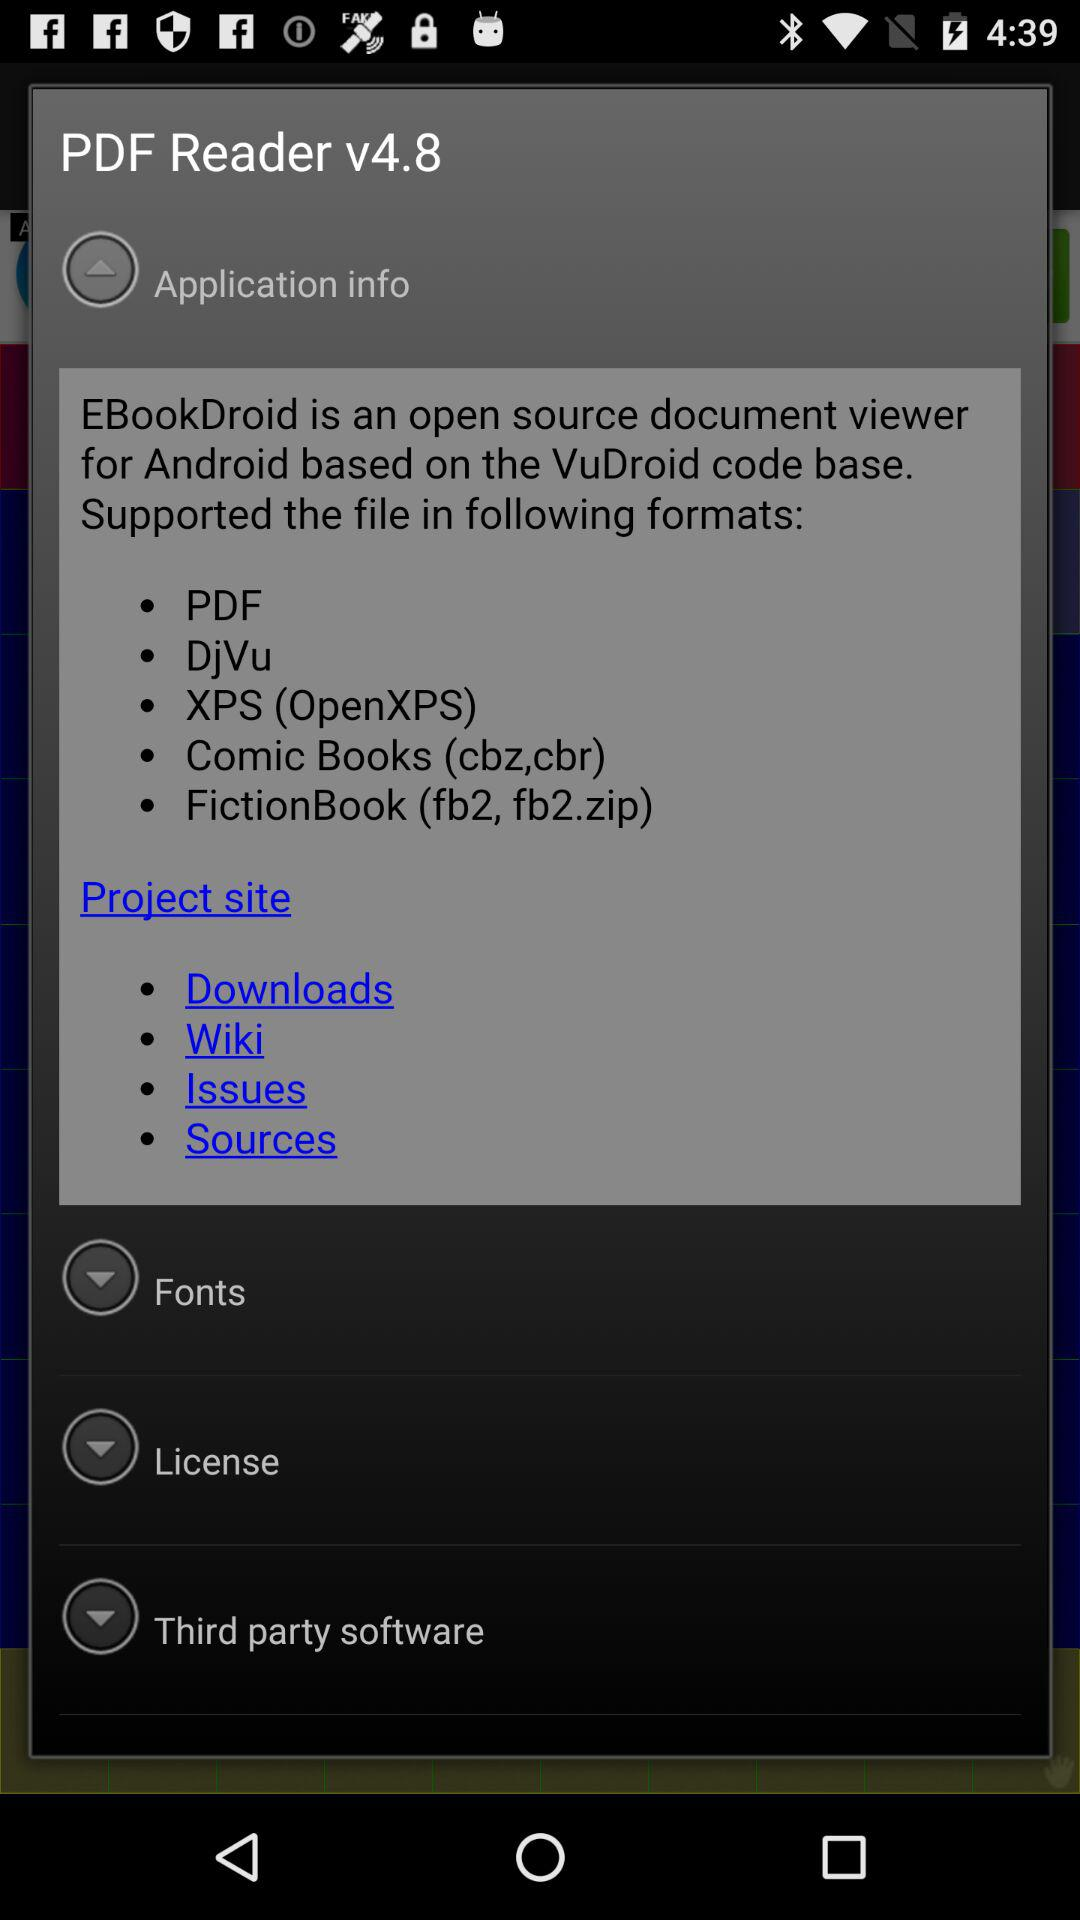What file formats are supported by EBookDroid? File formats supported by EBookDroid are PDF, DjVu, XPS (OpenXPS), Comic Books (cbz,cbr) and FictionBook (fb2, fb2.zip). 